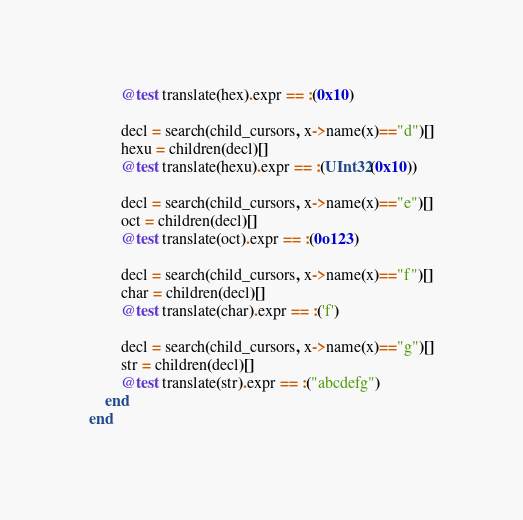Convert code to text. <code><loc_0><loc_0><loc_500><loc_500><_Julia_>        @test translate(hex).expr == :(0x10)

        decl = search(child_cursors, x->name(x)=="d")[]
        hexu = children(decl)[]
        @test translate(hexu).expr == :(UInt32(0x10))

        decl = search(child_cursors, x->name(x)=="e")[]
        oct = children(decl)[]
        @test translate(oct).expr == :(0o123)

        decl = search(child_cursors, x->name(x)=="f")[]
        char = children(decl)[]
        @test translate(char).expr == :('f')

        decl = search(child_cursors, x->name(x)=="g")[]
        str = children(decl)[]
        @test translate(str).expr == :("abcdefg")
    end
end
</code> 